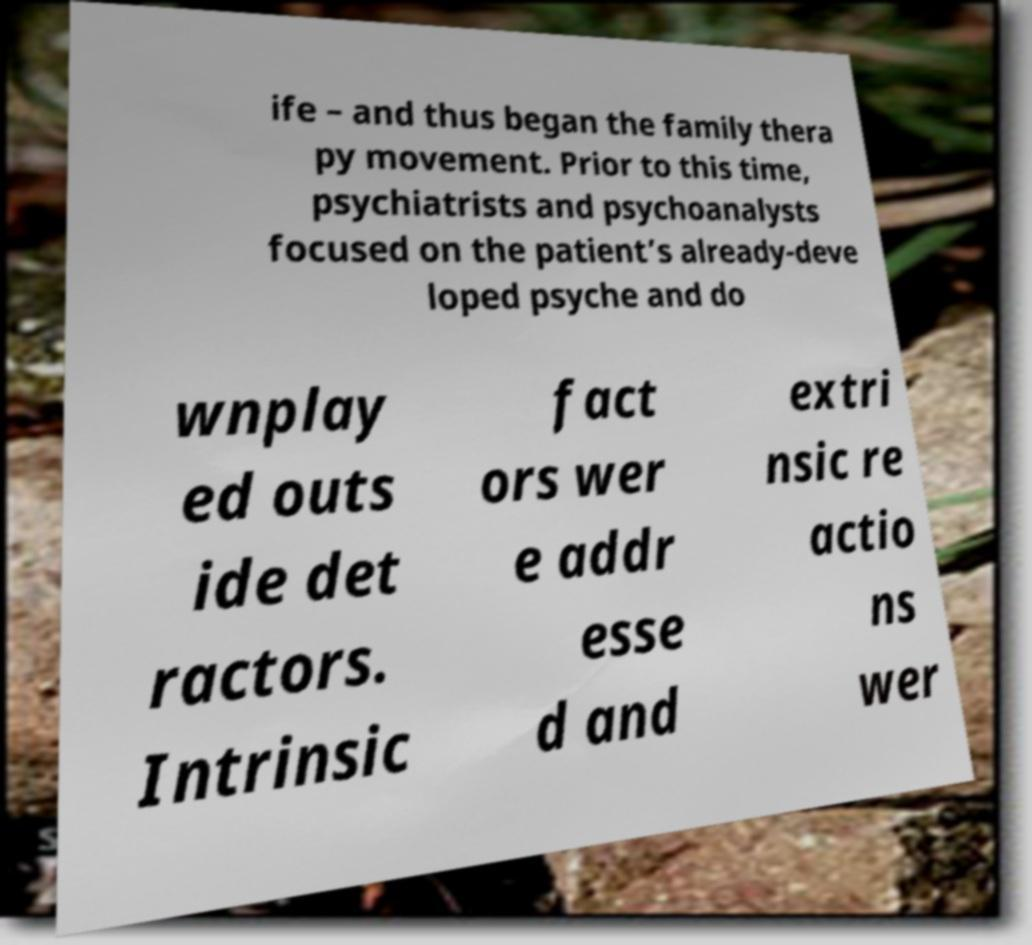For documentation purposes, I need the text within this image transcribed. Could you provide that? ife – and thus began the family thera py movement. Prior to this time, psychiatrists and psychoanalysts focused on the patient’s already-deve loped psyche and do wnplay ed outs ide det ractors. Intrinsic fact ors wer e addr esse d and extri nsic re actio ns wer 